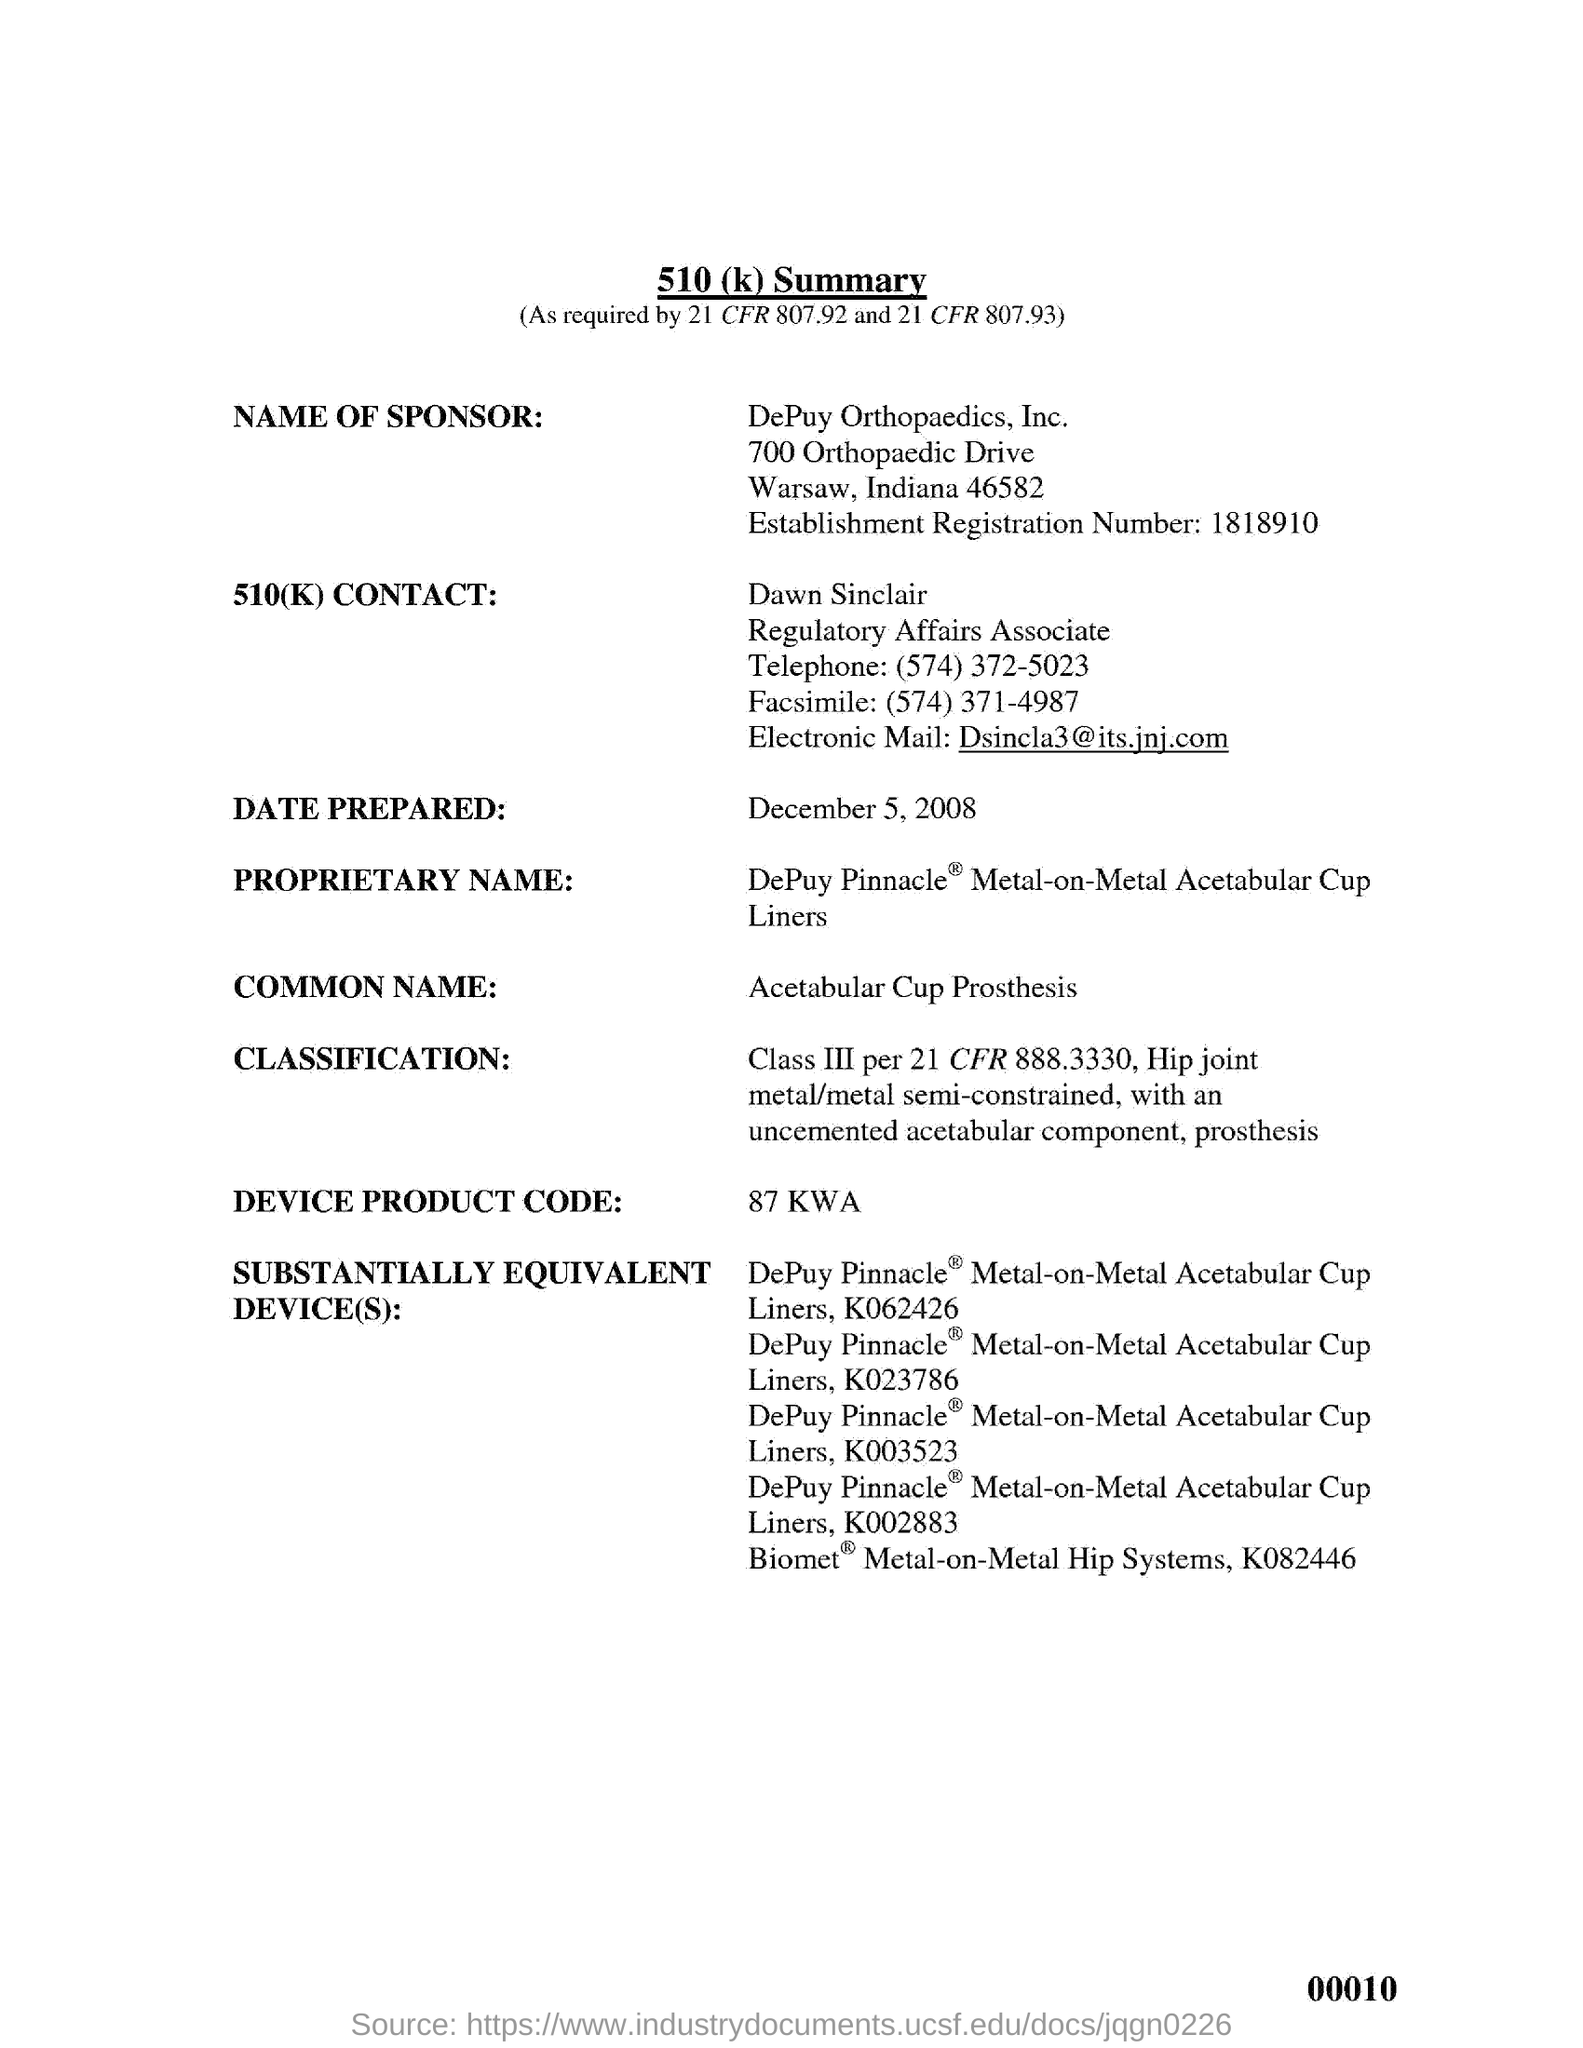Specify some key components in this picture. Dawn Sinclair's designation is Regulatory Affairs Associate. The device product code is 87 KWA. The telephone number of Dawn Sinclair is (574) 372-5023. The 510(k) CONTACT is named Dawn Sinclair. The common name for an acetabular cup prosthesis is a prosthetic device that is used to replace the acetabular socket of the hip joint. 